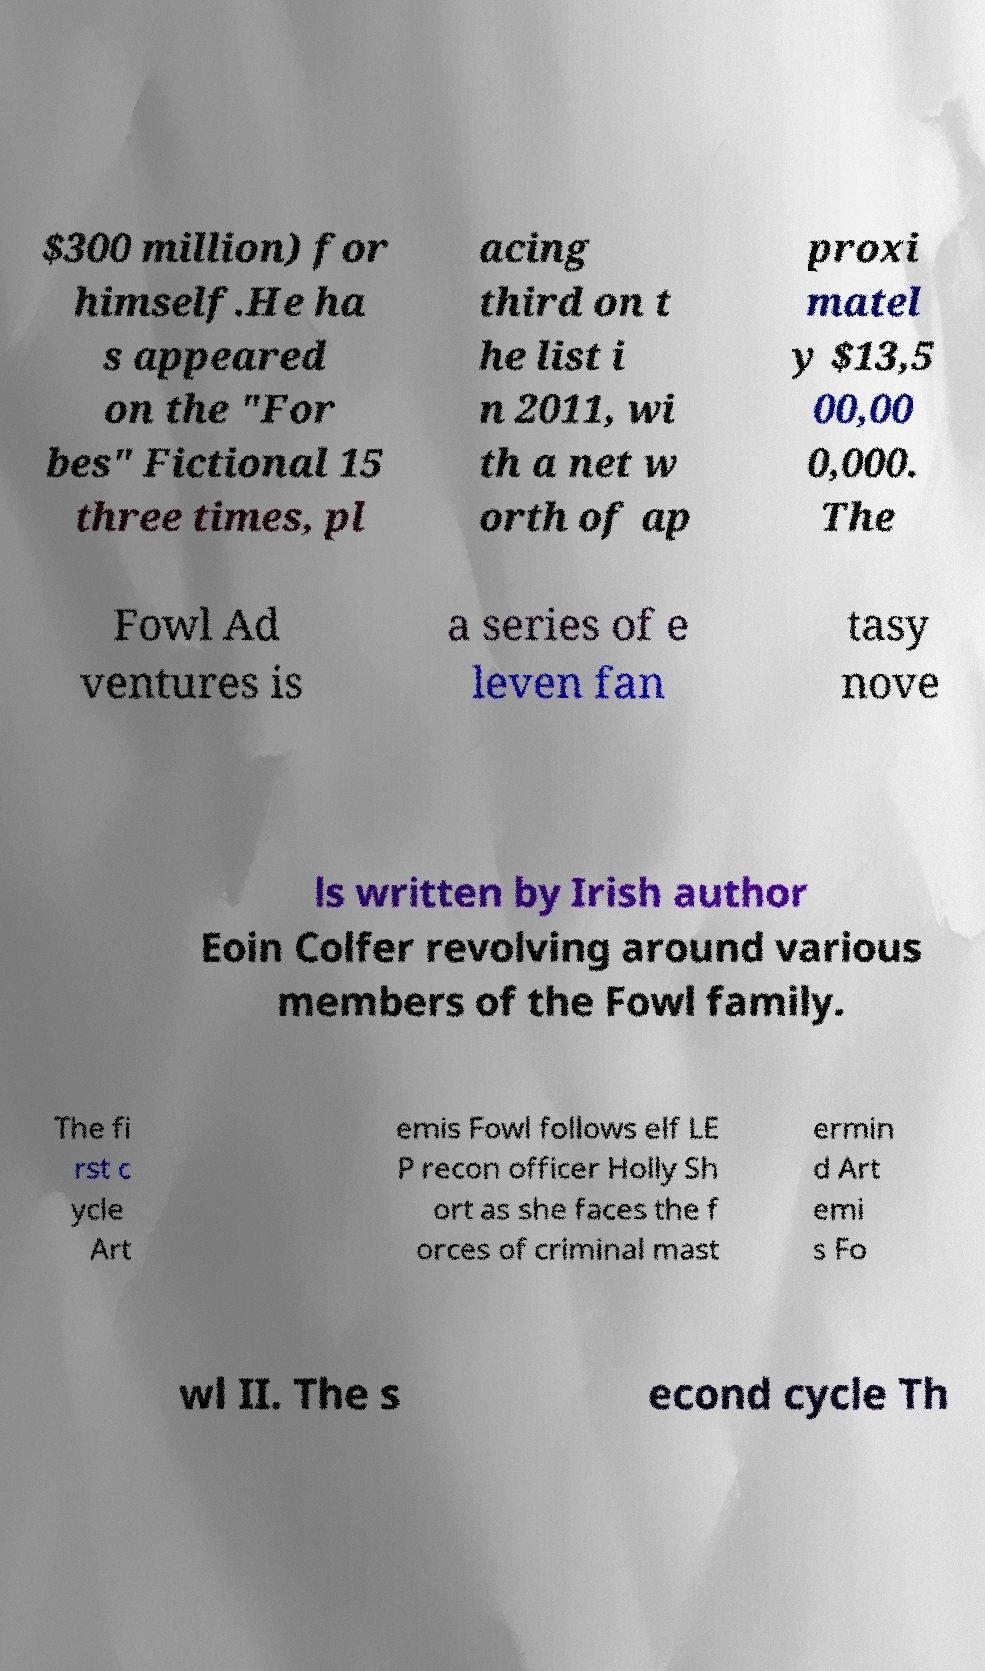Can you accurately transcribe the text from the provided image for me? $300 million) for himself.He ha s appeared on the "For bes" Fictional 15 three times, pl acing third on t he list i n 2011, wi th a net w orth of ap proxi matel y $13,5 00,00 0,000. The Fowl Ad ventures is a series of e leven fan tasy nove ls written by Irish author Eoin Colfer revolving around various members of the Fowl family. The fi rst c ycle Art emis Fowl follows elf LE P recon officer Holly Sh ort as she faces the f orces of criminal mast ermin d Art emi s Fo wl II. The s econd cycle Th 